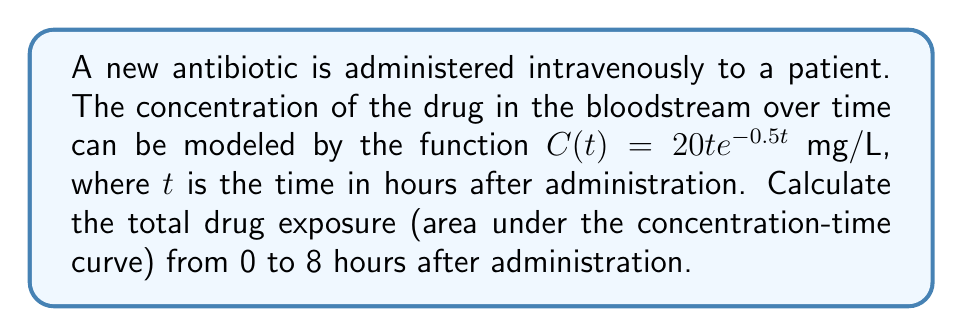Solve this math problem. To find the total drug exposure, we need to calculate the area under the curve of the concentration function from 0 to 8 hours. This can be done using integration:

1) The integral we need to evaluate is:
   $$\int_0^8 C(t) dt = \int_0^8 20t e^{-0.5t} dt$$

2) This integral can be solved using integration by parts. Let $u = t$ and $dv = 20e^{-0.5t}dt$. Then $du = dt$ and $v = -40e^{-0.5t}$.

3) Applying the integration by parts formula:
   $$\int_0^8 20t e^{-0.5t} dt = [-40te^{-0.5t}]_0^8 + \int_0^8 40e^{-0.5t} dt$$

4) Evaluating the first term:
   $[-40te^{-0.5t}]_0^8 = -40(8)e^{-0.5(8)} - (-40(0)e^{-0.5(0)}) = -320e^{-4}$

5) For the second integral:
   $$\int_0^8 40e^{-0.5t} dt = [-80e^{-0.5t}]_0^8 = -80e^{-4} - (-80) = 80 - 80e^{-4}$$

6) Combining the results:
   $$-320e^{-4} + 80 - 80e^{-4} = 80 - 400e^{-4}$$

7) Simplifying (e^{-4} ≈ 0.0183):
   $$80 - 400(0.0183) ≈ 80 - 7.32 = 72.68$$

The total drug exposure over 8 hours is approximately 72.68 mg·h/L.
Answer: 72.68 mg·h/L 